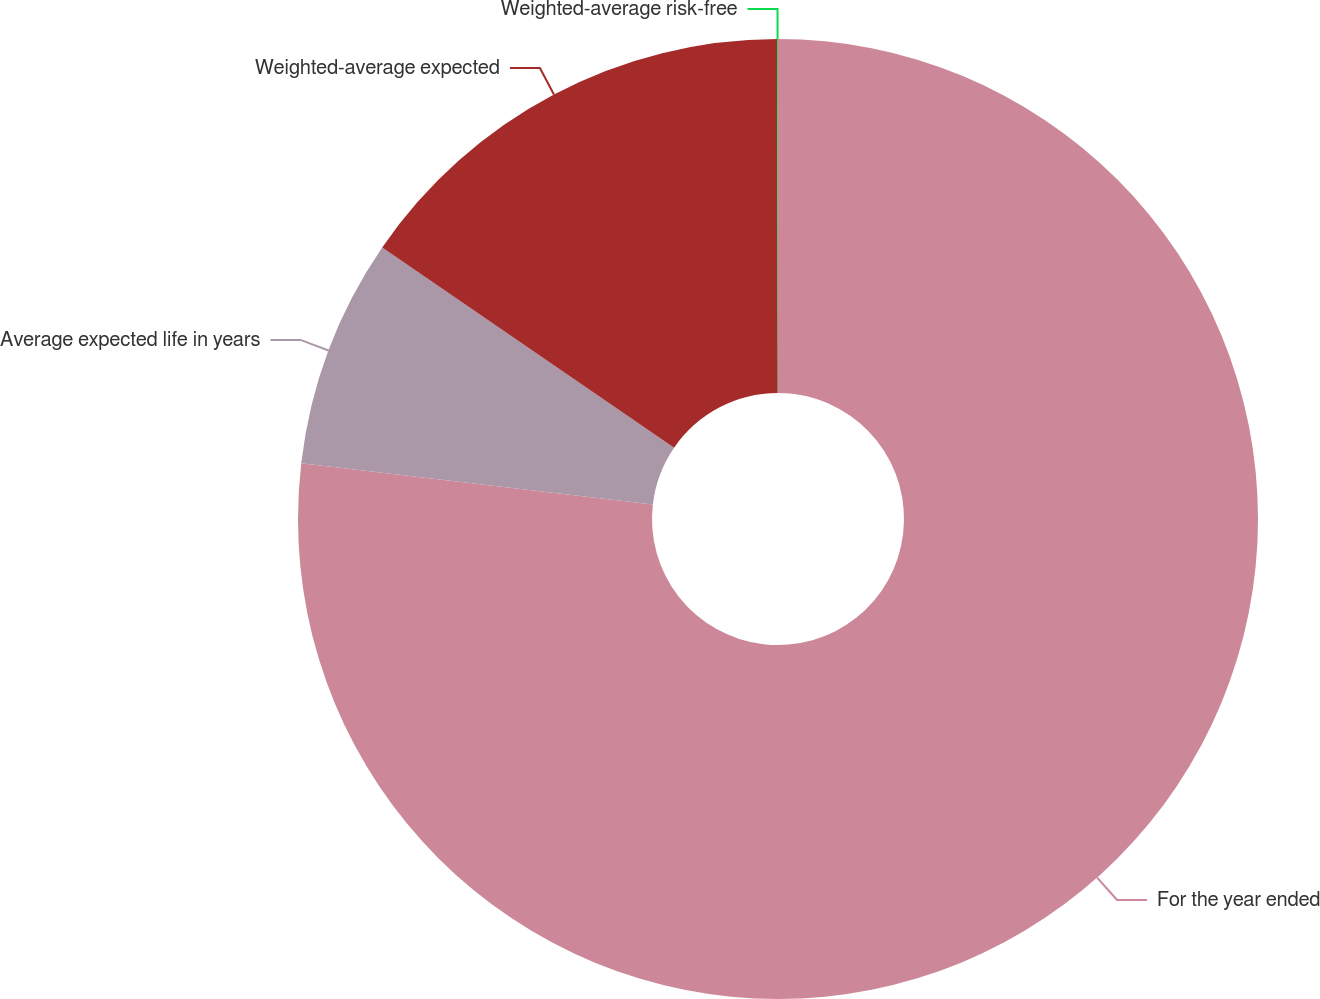<chart> <loc_0><loc_0><loc_500><loc_500><pie_chart><fcel>For the year ended<fcel>Average expected life in years<fcel>Weighted-average expected<fcel>Weighted-average risk-free<nl><fcel>76.85%<fcel>7.72%<fcel>15.4%<fcel>0.03%<nl></chart> 